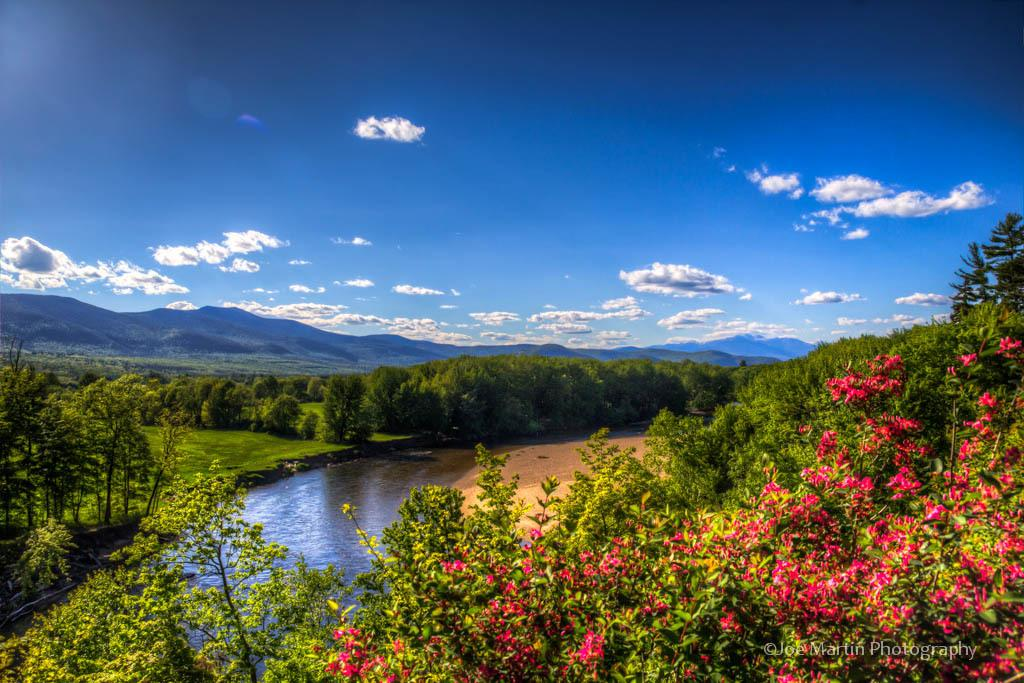What is located in the foreground of the image? There are flowers in the foreground of the image. What are the flowers associated with? The flowers are associated with plants. What can be seen in the background of the image? There is a river, trees, mountains, and the sky visible in the background of the image. What is the condition of the sky in the image? The sky is visible in the background of the image, and there are clouds present. What type of cake is being served on a skate in the image? There is no cake or skate present in the image; it features flowers in the foreground and a scenic background. 